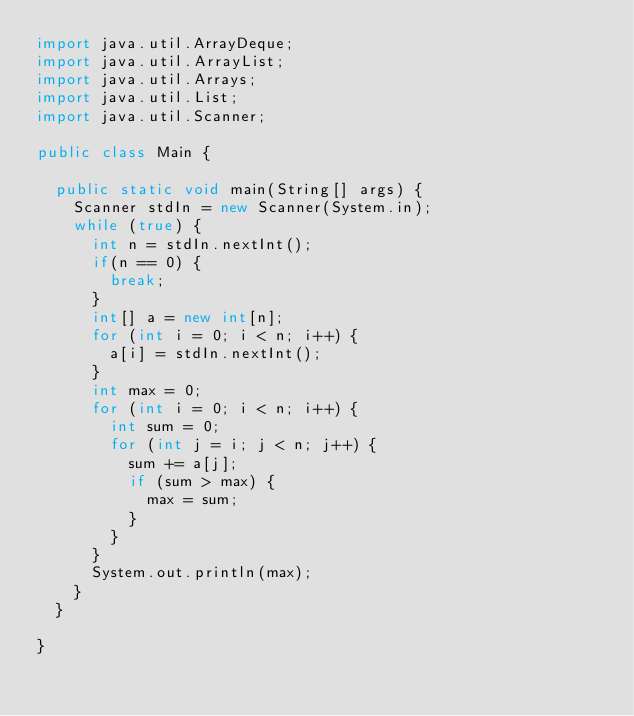Convert code to text. <code><loc_0><loc_0><loc_500><loc_500><_Java_>import java.util.ArrayDeque;
import java.util.ArrayList;
import java.util.Arrays;
import java.util.List;
import java.util.Scanner;

public class Main {

	public static void main(String[] args) {
		Scanner stdIn = new Scanner(System.in);
		while (true) {
			int n = stdIn.nextInt();
			if(n == 0) {
				break;
			}
			int[] a = new int[n];
			for (int i = 0; i < n; i++) {
				a[i] = stdIn.nextInt();
			}
			int max = 0;
			for (int i = 0; i < n; i++) {
				int sum = 0;
				for (int j = i; j < n; j++) {
					sum += a[j];
					if (sum > max) {
						max = sum;
					}
				}
			}
			System.out.println(max);
		}
	}

}</code> 